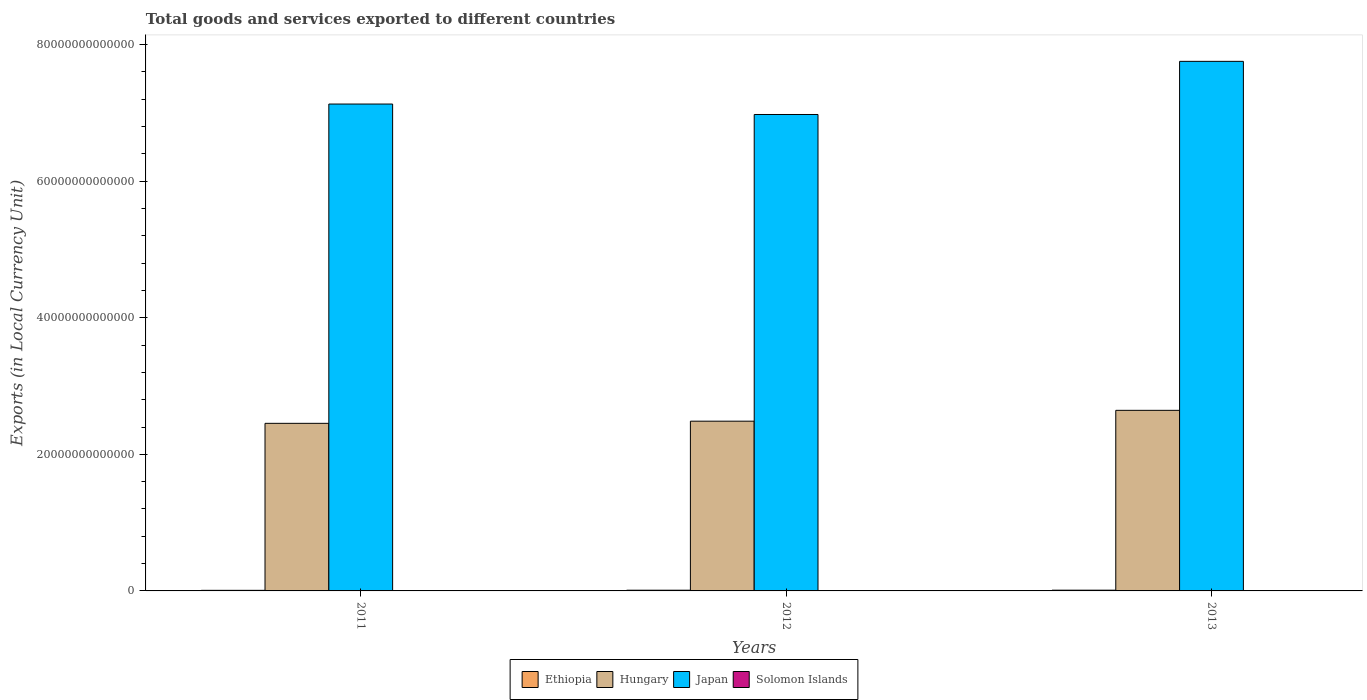How many different coloured bars are there?
Your response must be concise. 4. Are the number of bars per tick equal to the number of legend labels?
Your response must be concise. Yes. How many bars are there on the 1st tick from the left?
Make the answer very short. 4. What is the label of the 1st group of bars from the left?
Provide a short and direct response. 2011. What is the Amount of goods and services exports in Hungary in 2013?
Provide a succinct answer. 2.64e+13. Across all years, what is the maximum Amount of goods and services exports in Hungary?
Offer a very short reply. 2.64e+13. Across all years, what is the minimum Amount of goods and services exports in Japan?
Offer a very short reply. 6.98e+13. In which year was the Amount of goods and services exports in Ethiopia minimum?
Your answer should be compact. 2011. What is the total Amount of goods and services exports in Japan in the graph?
Offer a very short reply. 2.19e+14. What is the difference between the Amount of goods and services exports in Hungary in 2011 and that in 2012?
Keep it short and to the point. -3.15e+11. What is the difference between the Amount of goods and services exports in Hungary in 2011 and the Amount of goods and services exports in Japan in 2012?
Ensure brevity in your answer.  -4.52e+13. What is the average Amount of goods and services exports in Japan per year?
Provide a succinct answer. 7.29e+13. In the year 2011, what is the difference between the Amount of goods and services exports in Ethiopia and Amount of goods and services exports in Hungary?
Give a very brief answer. -2.45e+13. In how many years, is the Amount of goods and services exports in Hungary greater than 20000000000000 LCU?
Provide a short and direct response. 3. What is the ratio of the Amount of goods and services exports in Ethiopia in 2011 to that in 2012?
Give a very brief answer. 0.84. What is the difference between the highest and the second highest Amount of goods and services exports in Solomon Islands?
Your response must be concise. 3.05e+08. What is the difference between the highest and the lowest Amount of goods and services exports in Japan?
Your answer should be compact. 7.78e+12. In how many years, is the Amount of goods and services exports in Japan greater than the average Amount of goods and services exports in Japan taken over all years?
Your answer should be compact. 1. What does the 1st bar from the left in 2013 represents?
Provide a short and direct response. Ethiopia. What does the 3rd bar from the right in 2012 represents?
Your answer should be very brief. Hungary. Is it the case that in every year, the sum of the Amount of goods and services exports in Hungary and Amount of goods and services exports in Solomon Islands is greater than the Amount of goods and services exports in Japan?
Keep it short and to the point. No. How many bars are there?
Offer a terse response. 12. Are all the bars in the graph horizontal?
Your answer should be very brief. No. How many years are there in the graph?
Provide a succinct answer. 3. What is the difference between two consecutive major ticks on the Y-axis?
Your answer should be very brief. 2.00e+13. Does the graph contain grids?
Your answer should be compact. No. How many legend labels are there?
Offer a terse response. 4. What is the title of the graph?
Offer a terse response. Total goods and services exported to different countries. Does "France" appear as one of the legend labels in the graph?
Make the answer very short. No. What is the label or title of the Y-axis?
Provide a short and direct response. Exports (in Local Currency Unit). What is the Exports (in Local Currency Unit) of Ethiopia in 2011?
Keep it short and to the point. 8.60e+1. What is the Exports (in Local Currency Unit) of Hungary in 2011?
Keep it short and to the point. 2.45e+13. What is the Exports (in Local Currency Unit) in Japan in 2011?
Your answer should be compact. 7.13e+13. What is the Exports (in Local Currency Unit) in Solomon Islands in 2011?
Keep it short and to the point. 4.14e+09. What is the Exports (in Local Currency Unit) in Ethiopia in 2012?
Your answer should be very brief. 1.03e+11. What is the Exports (in Local Currency Unit) in Hungary in 2012?
Provide a succinct answer. 2.49e+13. What is the Exports (in Local Currency Unit) in Japan in 2012?
Keep it short and to the point. 6.98e+13. What is the Exports (in Local Currency Unit) in Solomon Islands in 2012?
Your answer should be very brief. 4.67e+09. What is the Exports (in Local Currency Unit) in Ethiopia in 2013?
Provide a succinct answer. 1.08e+11. What is the Exports (in Local Currency Unit) in Hungary in 2013?
Offer a terse response. 2.64e+13. What is the Exports (in Local Currency Unit) in Japan in 2013?
Your answer should be compact. 7.75e+13. What is the Exports (in Local Currency Unit) of Solomon Islands in 2013?
Give a very brief answer. 4.37e+09. Across all years, what is the maximum Exports (in Local Currency Unit) of Ethiopia?
Your response must be concise. 1.08e+11. Across all years, what is the maximum Exports (in Local Currency Unit) in Hungary?
Keep it short and to the point. 2.64e+13. Across all years, what is the maximum Exports (in Local Currency Unit) of Japan?
Offer a very short reply. 7.75e+13. Across all years, what is the maximum Exports (in Local Currency Unit) of Solomon Islands?
Your answer should be compact. 4.67e+09. Across all years, what is the minimum Exports (in Local Currency Unit) of Ethiopia?
Give a very brief answer. 8.60e+1. Across all years, what is the minimum Exports (in Local Currency Unit) in Hungary?
Your answer should be compact. 2.45e+13. Across all years, what is the minimum Exports (in Local Currency Unit) of Japan?
Your answer should be very brief. 6.98e+13. Across all years, what is the minimum Exports (in Local Currency Unit) in Solomon Islands?
Keep it short and to the point. 4.14e+09. What is the total Exports (in Local Currency Unit) in Ethiopia in the graph?
Give a very brief answer. 2.97e+11. What is the total Exports (in Local Currency Unit) in Hungary in the graph?
Give a very brief answer. 7.58e+13. What is the total Exports (in Local Currency Unit) in Japan in the graph?
Ensure brevity in your answer.  2.19e+14. What is the total Exports (in Local Currency Unit) in Solomon Islands in the graph?
Your answer should be very brief. 1.32e+1. What is the difference between the Exports (in Local Currency Unit) in Ethiopia in 2011 and that in 2012?
Your response must be concise. -1.69e+1. What is the difference between the Exports (in Local Currency Unit) in Hungary in 2011 and that in 2012?
Give a very brief answer. -3.15e+11. What is the difference between the Exports (in Local Currency Unit) in Japan in 2011 and that in 2012?
Your answer should be very brief. 1.53e+12. What is the difference between the Exports (in Local Currency Unit) in Solomon Islands in 2011 and that in 2012?
Give a very brief answer. -5.31e+08. What is the difference between the Exports (in Local Currency Unit) in Ethiopia in 2011 and that in 2013?
Make the answer very short. -2.23e+1. What is the difference between the Exports (in Local Currency Unit) of Hungary in 2011 and that in 2013?
Offer a terse response. -1.90e+12. What is the difference between the Exports (in Local Currency Unit) of Japan in 2011 and that in 2013?
Ensure brevity in your answer.  -6.25e+12. What is the difference between the Exports (in Local Currency Unit) in Solomon Islands in 2011 and that in 2013?
Ensure brevity in your answer.  -2.25e+08. What is the difference between the Exports (in Local Currency Unit) of Ethiopia in 2012 and that in 2013?
Your response must be concise. -5.34e+09. What is the difference between the Exports (in Local Currency Unit) in Hungary in 2012 and that in 2013?
Your answer should be very brief. -1.59e+12. What is the difference between the Exports (in Local Currency Unit) of Japan in 2012 and that in 2013?
Your answer should be very brief. -7.78e+12. What is the difference between the Exports (in Local Currency Unit) of Solomon Islands in 2012 and that in 2013?
Give a very brief answer. 3.05e+08. What is the difference between the Exports (in Local Currency Unit) of Ethiopia in 2011 and the Exports (in Local Currency Unit) of Hungary in 2012?
Give a very brief answer. -2.48e+13. What is the difference between the Exports (in Local Currency Unit) in Ethiopia in 2011 and the Exports (in Local Currency Unit) in Japan in 2012?
Offer a very short reply. -6.97e+13. What is the difference between the Exports (in Local Currency Unit) of Ethiopia in 2011 and the Exports (in Local Currency Unit) of Solomon Islands in 2012?
Give a very brief answer. 8.13e+1. What is the difference between the Exports (in Local Currency Unit) of Hungary in 2011 and the Exports (in Local Currency Unit) of Japan in 2012?
Offer a terse response. -4.52e+13. What is the difference between the Exports (in Local Currency Unit) of Hungary in 2011 and the Exports (in Local Currency Unit) of Solomon Islands in 2012?
Your answer should be very brief. 2.45e+13. What is the difference between the Exports (in Local Currency Unit) of Japan in 2011 and the Exports (in Local Currency Unit) of Solomon Islands in 2012?
Provide a short and direct response. 7.13e+13. What is the difference between the Exports (in Local Currency Unit) of Ethiopia in 2011 and the Exports (in Local Currency Unit) of Hungary in 2013?
Provide a short and direct response. -2.64e+13. What is the difference between the Exports (in Local Currency Unit) of Ethiopia in 2011 and the Exports (in Local Currency Unit) of Japan in 2013?
Keep it short and to the point. -7.75e+13. What is the difference between the Exports (in Local Currency Unit) of Ethiopia in 2011 and the Exports (in Local Currency Unit) of Solomon Islands in 2013?
Offer a very short reply. 8.16e+1. What is the difference between the Exports (in Local Currency Unit) of Hungary in 2011 and the Exports (in Local Currency Unit) of Japan in 2013?
Offer a terse response. -5.30e+13. What is the difference between the Exports (in Local Currency Unit) in Hungary in 2011 and the Exports (in Local Currency Unit) in Solomon Islands in 2013?
Provide a succinct answer. 2.45e+13. What is the difference between the Exports (in Local Currency Unit) of Japan in 2011 and the Exports (in Local Currency Unit) of Solomon Islands in 2013?
Make the answer very short. 7.13e+13. What is the difference between the Exports (in Local Currency Unit) of Ethiopia in 2012 and the Exports (in Local Currency Unit) of Hungary in 2013?
Give a very brief answer. -2.63e+13. What is the difference between the Exports (in Local Currency Unit) in Ethiopia in 2012 and the Exports (in Local Currency Unit) in Japan in 2013?
Your response must be concise. -7.74e+13. What is the difference between the Exports (in Local Currency Unit) in Ethiopia in 2012 and the Exports (in Local Currency Unit) in Solomon Islands in 2013?
Give a very brief answer. 9.85e+1. What is the difference between the Exports (in Local Currency Unit) of Hungary in 2012 and the Exports (in Local Currency Unit) of Japan in 2013?
Your answer should be compact. -5.27e+13. What is the difference between the Exports (in Local Currency Unit) of Hungary in 2012 and the Exports (in Local Currency Unit) of Solomon Islands in 2013?
Offer a very short reply. 2.49e+13. What is the difference between the Exports (in Local Currency Unit) of Japan in 2012 and the Exports (in Local Currency Unit) of Solomon Islands in 2013?
Your answer should be compact. 6.98e+13. What is the average Exports (in Local Currency Unit) of Ethiopia per year?
Offer a terse response. 9.90e+1. What is the average Exports (in Local Currency Unit) of Hungary per year?
Make the answer very short. 2.53e+13. What is the average Exports (in Local Currency Unit) of Japan per year?
Your answer should be very brief. 7.29e+13. What is the average Exports (in Local Currency Unit) in Solomon Islands per year?
Offer a terse response. 4.39e+09. In the year 2011, what is the difference between the Exports (in Local Currency Unit) of Ethiopia and Exports (in Local Currency Unit) of Hungary?
Your answer should be compact. -2.45e+13. In the year 2011, what is the difference between the Exports (in Local Currency Unit) of Ethiopia and Exports (in Local Currency Unit) of Japan?
Offer a terse response. -7.12e+13. In the year 2011, what is the difference between the Exports (in Local Currency Unit) in Ethiopia and Exports (in Local Currency Unit) in Solomon Islands?
Your answer should be compact. 8.18e+1. In the year 2011, what is the difference between the Exports (in Local Currency Unit) in Hungary and Exports (in Local Currency Unit) in Japan?
Make the answer very short. -4.68e+13. In the year 2011, what is the difference between the Exports (in Local Currency Unit) in Hungary and Exports (in Local Currency Unit) in Solomon Islands?
Provide a succinct answer. 2.45e+13. In the year 2011, what is the difference between the Exports (in Local Currency Unit) in Japan and Exports (in Local Currency Unit) in Solomon Islands?
Give a very brief answer. 7.13e+13. In the year 2012, what is the difference between the Exports (in Local Currency Unit) of Ethiopia and Exports (in Local Currency Unit) of Hungary?
Your answer should be very brief. -2.48e+13. In the year 2012, what is the difference between the Exports (in Local Currency Unit) in Ethiopia and Exports (in Local Currency Unit) in Japan?
Your response must be concise. -6.97e+13. In the year 2012, what is the difference between the Exports (in Local Currency Unit) in Ethiopia and Exports (in Local Currency Unit) in Solomon Islands?
Your answer should be compact. 9.82e+1. In the year 2012, what is the difference between the Exports (in Local Currency Unit) of Hungary and Exports (in Local Currency Unit) of Japan?
Provide a succinct answer. -4.49e+13. In the year 2012, what is the difference between the Exports (in Local Currency Unit) of Hungary and Exports (in Local Currency Unit) of Solomon Islands?
Provide a succinct answer. 2.49e+13. In the year 2012, what is the difference between the Exports (in Local Currency Unit) in Japan and Exports (in Local Currency Unit) in Solomon Islands?
Offer a terse response. 6.98e+13. In the year 2013, what is the difference between the Exports (in Local Currency Unit) of Ethiopia and Exports (in Local Currency Unit) of Hungary?
Your answer should be compact. -2.63e+13. In the year 2013, what is the difference between the Exports (in Local Currency Unit) of Ethiopia and Exports (in Local Currency Unit) of Japan?
Your response must be concise. -7.74e+13. In the year 2013, what is the difference between the Exports (in Local Currency Unit) of Ethiopia and Exports (in Local Currency Unit) of Solomon Islands?
Your response must be concise. 1.04e+11. In the year 2013, what is the difference between the Exports (in Local Currency Unit) in Hungary and Exports (in Local Currency Unit) in Japan?
Your answer should be very brief. -5.11e+13. In the year 2013, what is the difference between the Exports (in Local Currency Unit) of Hungary and Exports (in Local Currency Unit) of Solomon Islands?
Keep it short and to the point. 2.64e+13. In the year 2013, what is the difference between the Exports (in Local Currency Unit) in Japan and Exports (in Local Currency Unit) in Solomon Islands?
Provide a short and direct response. 7.75e+13. What is the ratio of the Exports (in Local Currency Unit) in Ethiopia in 2011 to that in 2012?
Offer a terse response. 0.84. What is the ratio of the Exports (in Local Currency Unit) of Hungary in 2011 to that in 2012?
Your response must be concise. 0.99. What is the ratio of the Exports (in Local Currency Unit) in Japan in 2011 to that in 2012?
Provide a short and direct response. 1.02. What is the ratio of the Exports (in Local Currency Unit) in Solomon Islands in 2011 to that in 2012?
Offer a very short reply. 0.89. What is the ratio of the Exports (in Local Currency Unit) in Ethiopia in 2011 to that in 2013?
Offer a terse response. 0.79. What is the ratio of the Exports (in Local Currency Unit) in Hungary in 2011 to that in 2013?
Give a very brief answer. 0.93. What is the ratio of the Exports (in Local Currency Unit) of Japan in 2011 to that in 2013?
Provide a short and direct response. 0.92. What is the ratio of the Exports (in Local Currency Unit) in Solomon Islands in 2011 to that in 2013?
Keep it short and to the point. 0.95. What is the ratio of the Exports (in Local Currency Unit) in Ethiopia in 2012 to that in 2013?
Your answer should be very brief. 0.95. What is the ratio of the Exports (in Local Currency Unit) of Hungary in 2012 to that in 2013?
Keep it short and to the point. 0.94. What is the ratio of the Exports (in Local Currency Unit) of Japan in 2012 to that in 2013?
Make the answer very short. 0.9. What is the ratio of the Exports (in Local Currency Unit) in Solomon Islands in 2012 to that in 2013?
Your answer should be very brief. 1.07. What is the difference between the highest and the second highest Exports (in Local Currency Unit) of Ethiopia?
Keep it short and to the point. 5.34e+09. What is the difference between the highest and the second highest Exports (in Local Currency Unit) of Hungary?
Keep it short and to the point. 1.59e+12. What is the difference between the highest and the second highest Exports (in Local Currency Unit) in Japan?
Your answer should be compact. 6.25e+12. What is the difference between the highest and the second highest Exports (in Local Currency Unit) in Solomon Islands?
Keep it short and to the point. 3.05e+08. What is the difference between the highest and the lowest Exports (in Local Currency Unit) of Ethiopia?
Ensure brevity in your answer.  2.23e+1. What is the difference between the highest and the lowest Exports (in Local Currency Unit) in Hungary?
Offer a very short reply. 1.90e+12. What is the difference between the highest and the lowest Exports (in Local Currency Unit) of Japan?
Make the answer very short. 7.78e+12. What is the difference between the highest and the lowest Exports (in Local Currency Unit) in Solomon Islands?
Your response must be concise. 5.31e+08. 